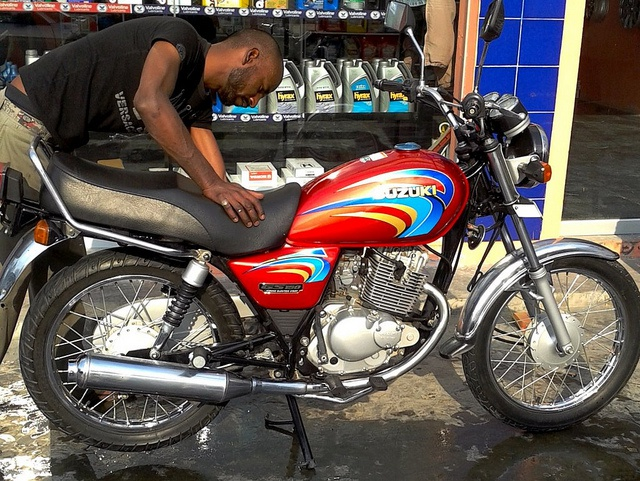Describe the objects in this image and their specific colors. I can see motorcycle in gray, black, ivory, and darkgray tones, people in gray, black, maroon, and brown tones, and bottle in gray, darkgray, ivory, and black tones in this image. 